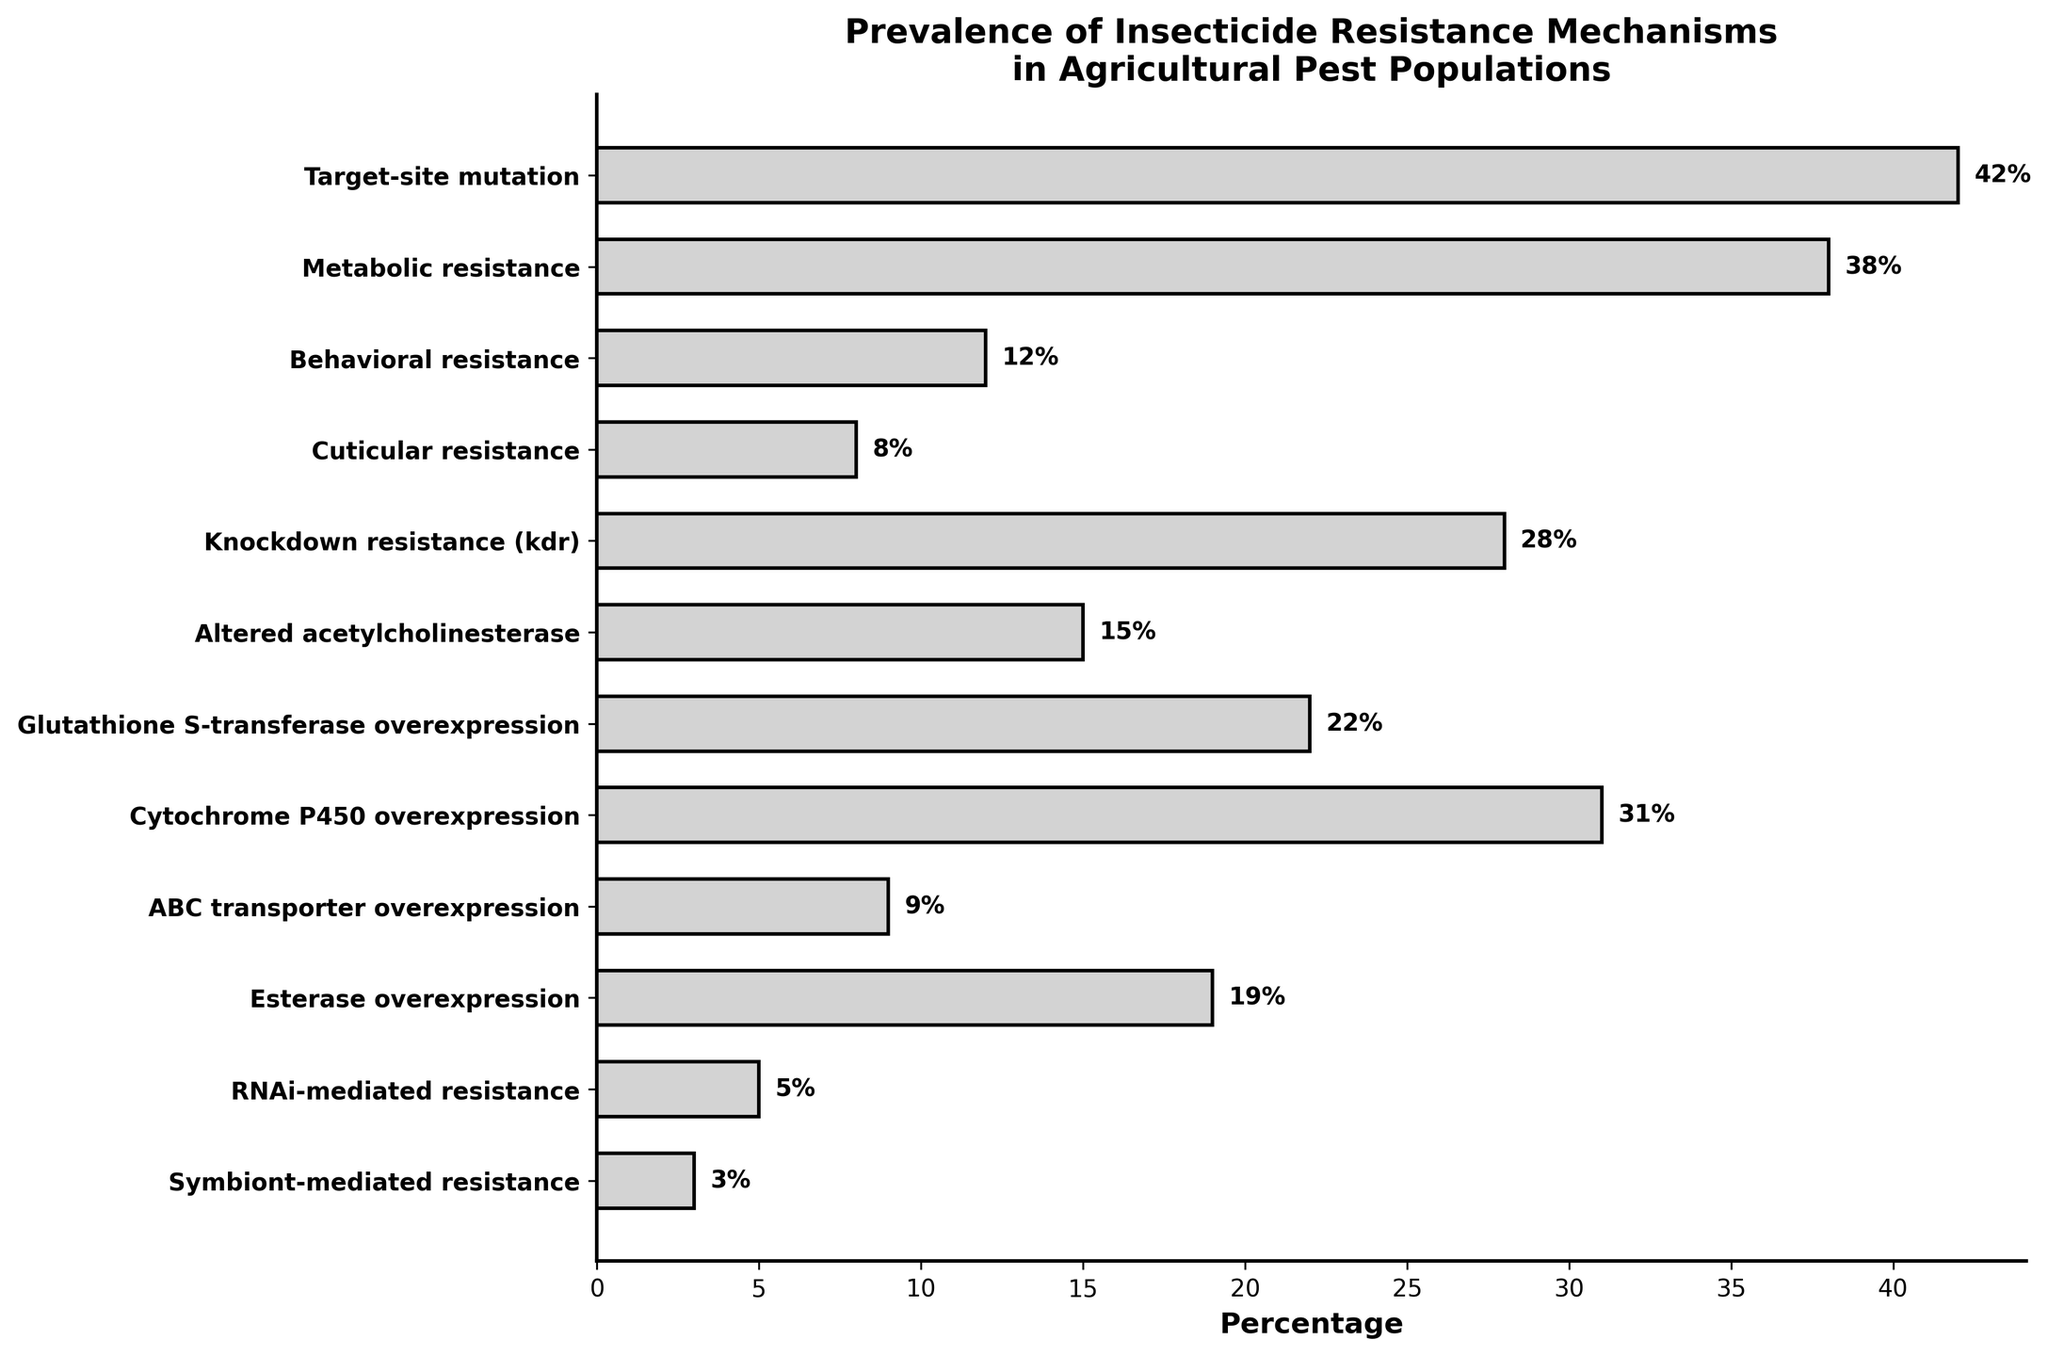What's the most prevalent insecticide resistance mechanism? To determine the most prevalent mechanism, look for the longest bar in the chart. The bar with the maximum length corresponds to "Target-site mutation" at 42%.
Answer: Target-site mutation Which two mechanisms have the smallest difference in their percentages? To find this, examine the neighboring percentages and identify the pair with the smallest difference. "Target-site mutation" (42%) and "Metabolic resistance" (38%) have a difference of 4%, while "Behavioral resistance" (12%) and "Cuticular resistance" (8%) have a difference of 4%, and "ABC transporter overexpression" (9%) and "Esterase overexpression" (19%) have a difference of 10%.
Answer: Behavioral resistance and Cuticular resistance OR Target-site mutation and Metabolic resistance What percentage of mechanisms have a prevalence of less than 10%? Count the number of mechanisms with values under 10% and divide by the total number of mechanisms. The mechanisms under 10% are "Cuticular resistance" (8%), "ABC transporter overexpression" (9%), "RNAi-mediated resistance" (5%), and "Symbiont-mediated resistance" (3%), making it 4 out of 12.
Answer: 33.3% How much more prevalent is Target-site mutation compared to Behavioral resistance? Subtract the percentage of "Behavioral resistance" from "Target-site mutation". (42% - 12% = 30%)
Answer: 30% Which mechanism is the least prevalent and what is its percentage? Look for the bar with the shortest length. "Symbiont-mediated resistance" has the shortest bar with a value of 3%.
Answer: Symbiont-mediated resistance, 3% Are there more resistance mechanisms above or below 20% prevalence? Count the number of mechanisms above 20% (Target-site mutation, Metabolic resistance, Knockdown resistance, Cytochrome P450 overexpression, Glutathione S-transferase overexpression) which is 5. Count the number below 20% (Behavioral resistance, Cuticular resistance, ABC transporter overexpression, Esterase overexpression, RNAi-mediated resistance, Symbiont-mediated resistance) which is 6.
Answer: Below 20% What is the combined prevalence of the three least prevalent mechanisms? Add the percentages of the three least prevalent mechanisms: "Symbiont-mediated resistance" (3%), "RNAi-mediated resistance" (5%), "Cuticular resistance" (8%). (3% + 5% + 8% = 16%)
Answer: 16% Which mechanisms have exactly twice the prevalence of another mechanism on the list? Compare the percentages to find pairs where one is exactly double the other. "Behavioral resistance" (12%) is double "Symbiont-mediated resistance" (3% + 3%), "Esterase overexpression" (19%) is close but does not exactly double any precise mechanism.
Answer: Behavioral resistance (twice Symbiont-mediated resistance) Which resistance mechanism closely matches the prevalence of Knockdown resistance? Search for bars with percentages close to "Knockdown resistance" (28%), the next closest is "Cytochrome P450 overexpression" with 31%.
Answer: Cytochrome P450 overexpression 